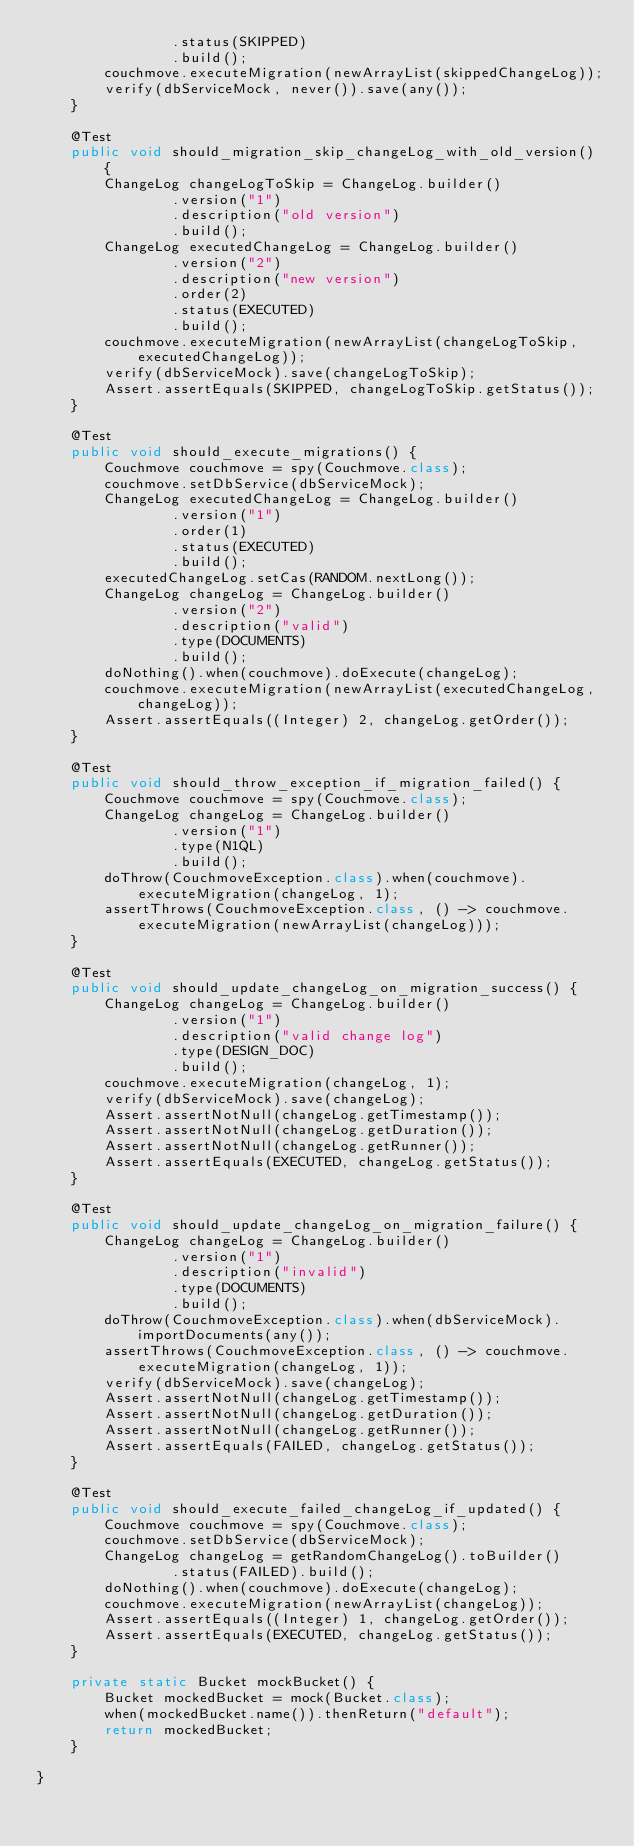<code> <loc_0><loc_0><loc_500><loc_500><_Java_>                .status(SKIPPED)
                .build();
        couchmove.executeMigration(newArrayList(skippedChangeLog));
        verify(dbServiceMock, never()).save(any());
    }

    @Test
    public void should_migration_skip_changeLog_with_old_version() {
        ChangeLog changeLogToSkip = ChangeLog.builder()
                .version("1")
                .description("old version")
                .build();
        ChangeLog executedChangeLog = ChangeLog.builder()
                .version("2")
                .description("new version")
                .order(2)
                .status(EXECUTED)
                .build();
        couchmove.executeMigration(newArrayList(changeLogToSkip, executedChangeLog));
        verify(dbServiceMock).save(changeLogToSkip);
        Assert.assertEquals(SKIPPED, changeLogToSkip.getStatus());
    }

    @Test
    public void should_execute_migrations() {
        Couchmove couchmove = spy(Couchmove.class);
        couchmove.setDbService(dbServiceMock);
        ChangeLog executedChangeLog = ChangeLog.builder()
                .version("1")
                .order(1)
                .status(EXECUTED)
                .build();
        executedChangeLog.setCas(RANDOM.nextLong());
        ChangeLog changeLog = ChangeLog.builder()
                .version("2")
                .description("valid")
                .type(DOCUMENTS)
                .build();
        doNothing().when(couchmove).doExecute(changeLog);
        couchmove.executeMigration(newArrayList(executedChangeLog, changeLog));
        Assert.assertEquals((Integer) 2, changeLog.getOrder());
    }

    @Test
    public void should_throw_exception_if_migration_failed() {
        Couchmove couchmove = spy(Couchmove.class);
        ChangeLog changeLog = ChangeLog.builder()
                .version("1")
                .type(N1QL)
                .build();
        doThrow(CouchmoveException.class).when(couchmove).executeMigration(changeLog, 1);
        assertThrows(CouchmoveException.class, () -> couchmove.executeMigration(newArrayList(changeLog)));
    }

    @Test
    public void should_update_changeLog_on_migration_success() {
        ChangeLog changeLog = ChangeLog.builder()
                .version("1")
                .description("valid change log")
                .type(DESIGN_DOC)
                .build();
        couchmove.executeMigration(changeLog, 1);
        verify(dbServiceMock).save(changeLog);
        Assert.assertNotNull(changeLog.getTimestamp());
        Assert.assertNotNull(changeLog.getDuration());
        Assert.assertNotNull(changeLog.getRunner());
        Assert.assertEquals(EXECUTED, changeLog.getStatus());
    }

    @Test
    public void should_update_changeLog_on_migration_failure() {
        ChangeLog changeLog = ChangeLog.builder()
                .version("1")
                .description("invalid")
                .type(DOCUMENTS)
                .build();
        doThrow(CouchmoveException.class).when(dbServiceMock).importDocuments(any());
        assertThrows(CouchmoveException.class, () -> couchmove.executeMigration(changeLog, 1));
        verify(dbServiceMock).save(changeLog);
        Assert.assertNotNull(changeLog.getTimestamp());
        Assert.assertNotNull(changeLog.getDuration());
        Assert.assertNotNull(changeLog.getRunner());
        Assert.assertEquals(FAILED, changeLog.getStatus());
    }

    @Test
    public void should_execute_failed_changeLog_if_updated() {
        Couchmove couchmove = spy(Couchmove.class);
        couchmove.setDbService(dbServiceMock);
        ChangeLog changeLog = getRandomChangeLog().toBuilder()
                .status(FAILED).build();
        doNothing().when(couchmove).doExecute(changeLog);
        couchmove.executeMigration(newArrayList(changeLog));
        Assert.assertEquals((Integer) 1, changeLog.getOrder());
        Assert.assertEquals(EXECUTED, changeLog.getStatus());
    }

    private static Bucket mockBucket() {
        Bucket mockedBucket = mock(Bucket.class);
        when(mockedBucket.name()).thenReturn("default");
        return mockedBucket;
    }

}
</code> 